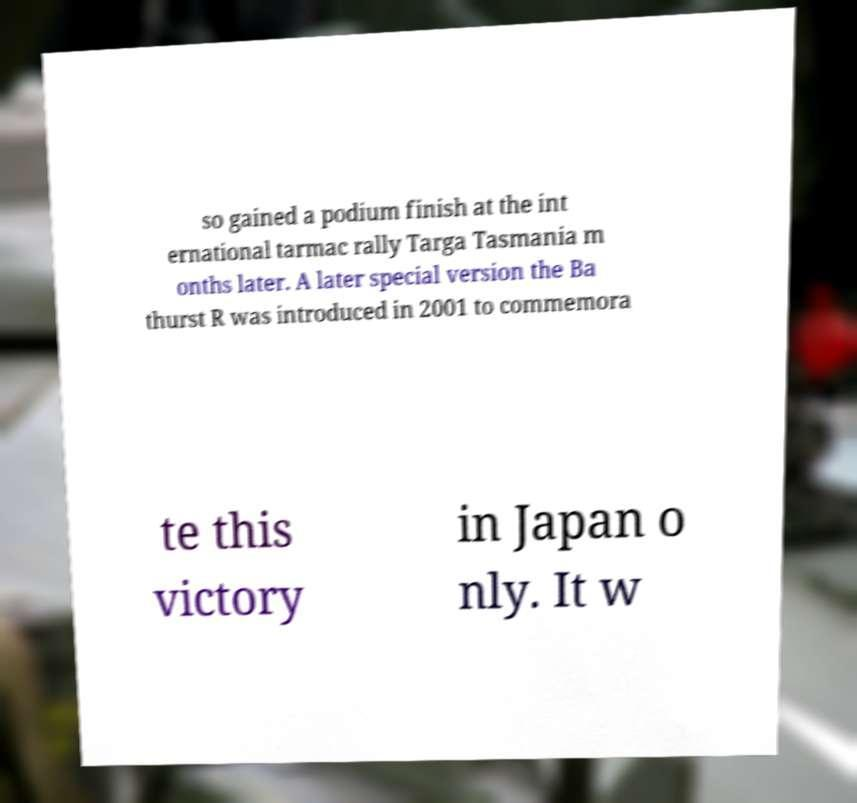Can you read and provide the text displayed in the image?This photo seems to have some interesting text. Can you extract and type it out for me? so gained a podium finish at the int ernational tarmac rally Targa Tasmania m onths later. A later special version the Ba thurst R was introduced in 2001 to commemora te this victory in Japan o nly. It w 